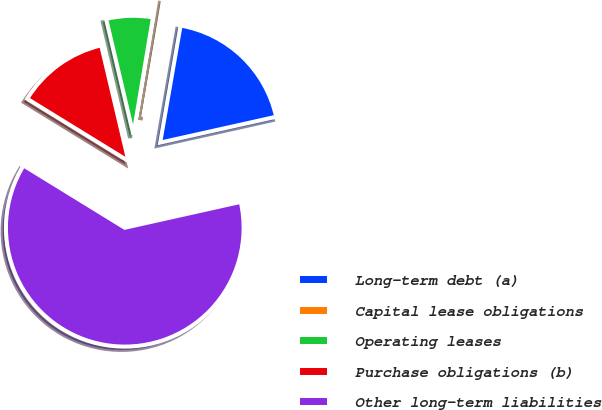Convert chart to OTSL. <chart><loc_0><loc_0><loc_500><loc_500><pie_chart><fcel>Long-term debt (a)<fcel>Capital lease obligations<fcel>Operating leases<fcel>Purchase obligations (b)<fcel>Other long-term liabilities<nl><fcel>18.76%<fcel>0.11%<fcel>6.32%<fcel>12.54%<fcel>62.27%<nl></chart> 